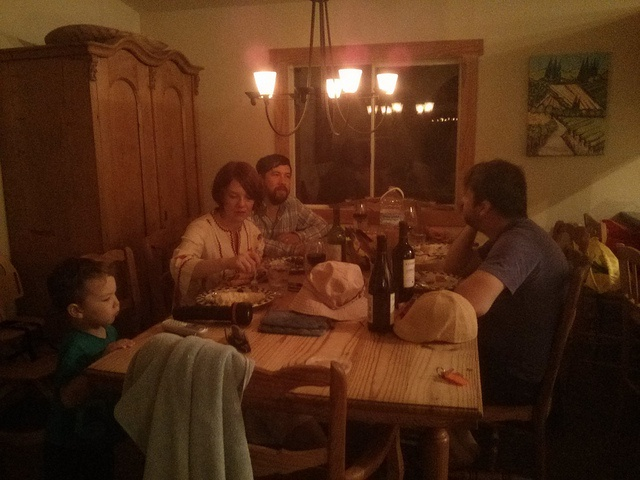Describe the objects in this image and their specific colors. I can see dining table in olive, maroon, brown, and black tones, people in olive, black, maroon, and brown tones, chair in olive, black, maroon, and brown tones, people in olive, maroon, and brown tones, and people in olive, black, maroon, and brown tones in this image. 